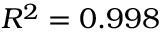<formula> <loc_0><loc_0><loc_500><loc_500>R ^ { 2 } = 0 . 9 9 8</formula> 